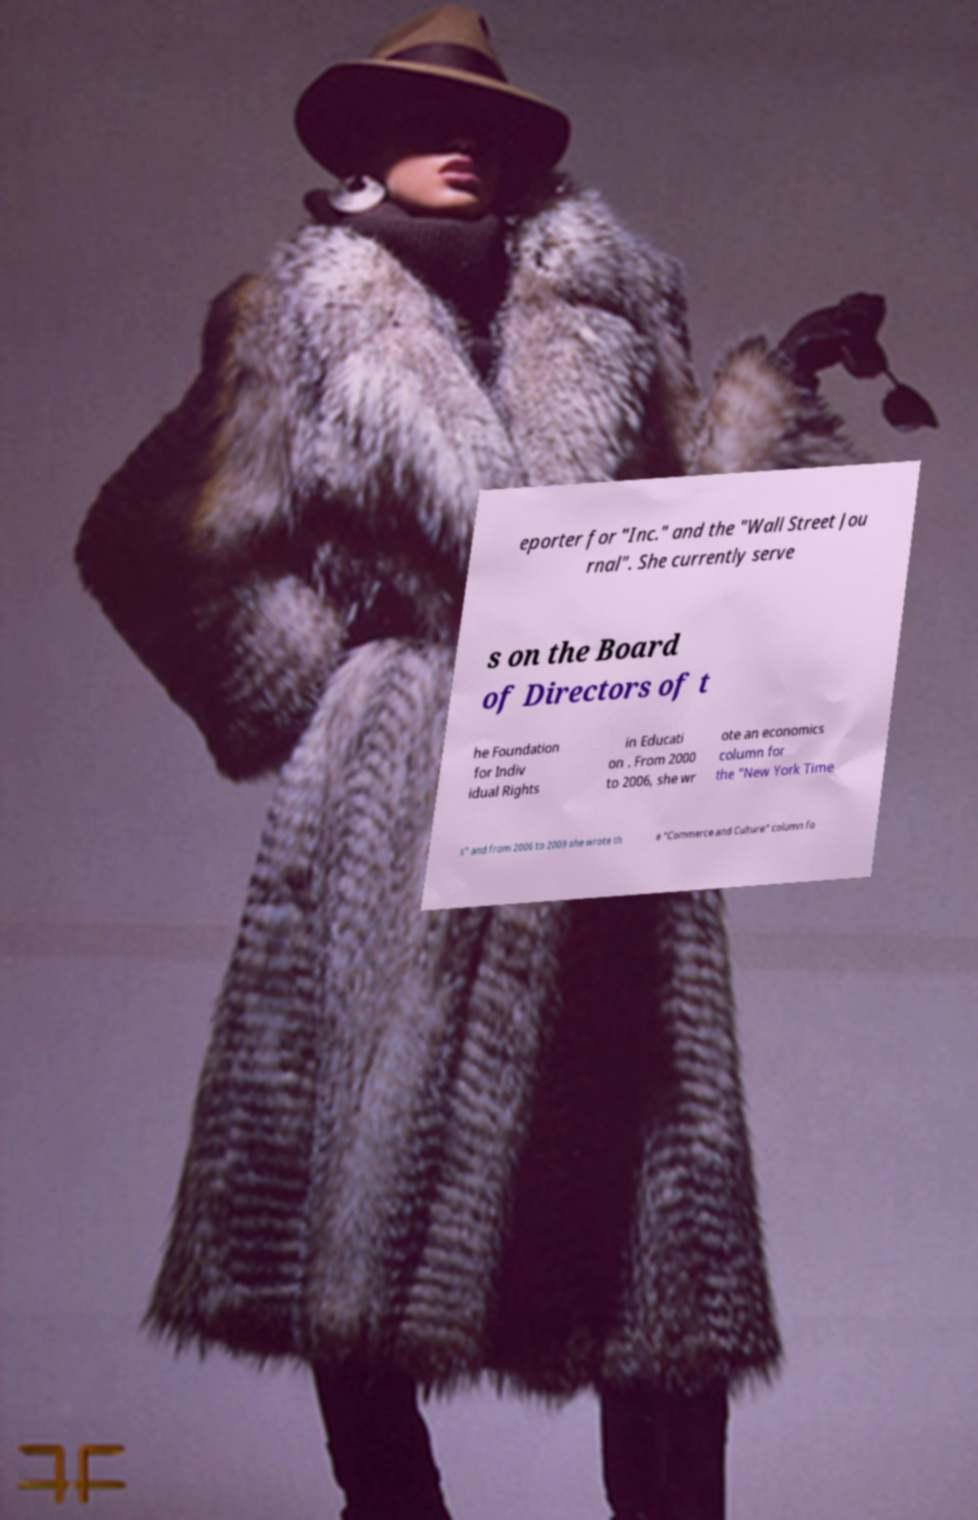Could you assist in decoding the text presented in this image and type it out clearly? eporter for "Inc." and the "Wall Street Jou rnal". She currently serve s on the Board of Directors of t he Foundation for Indiv idual Rights in Educati on . From 2000 to 2006, she wr ote an economics column for the "New York Time s" and from 2006 to 2009 she wrote th e "Commerce and Culture" column fo 